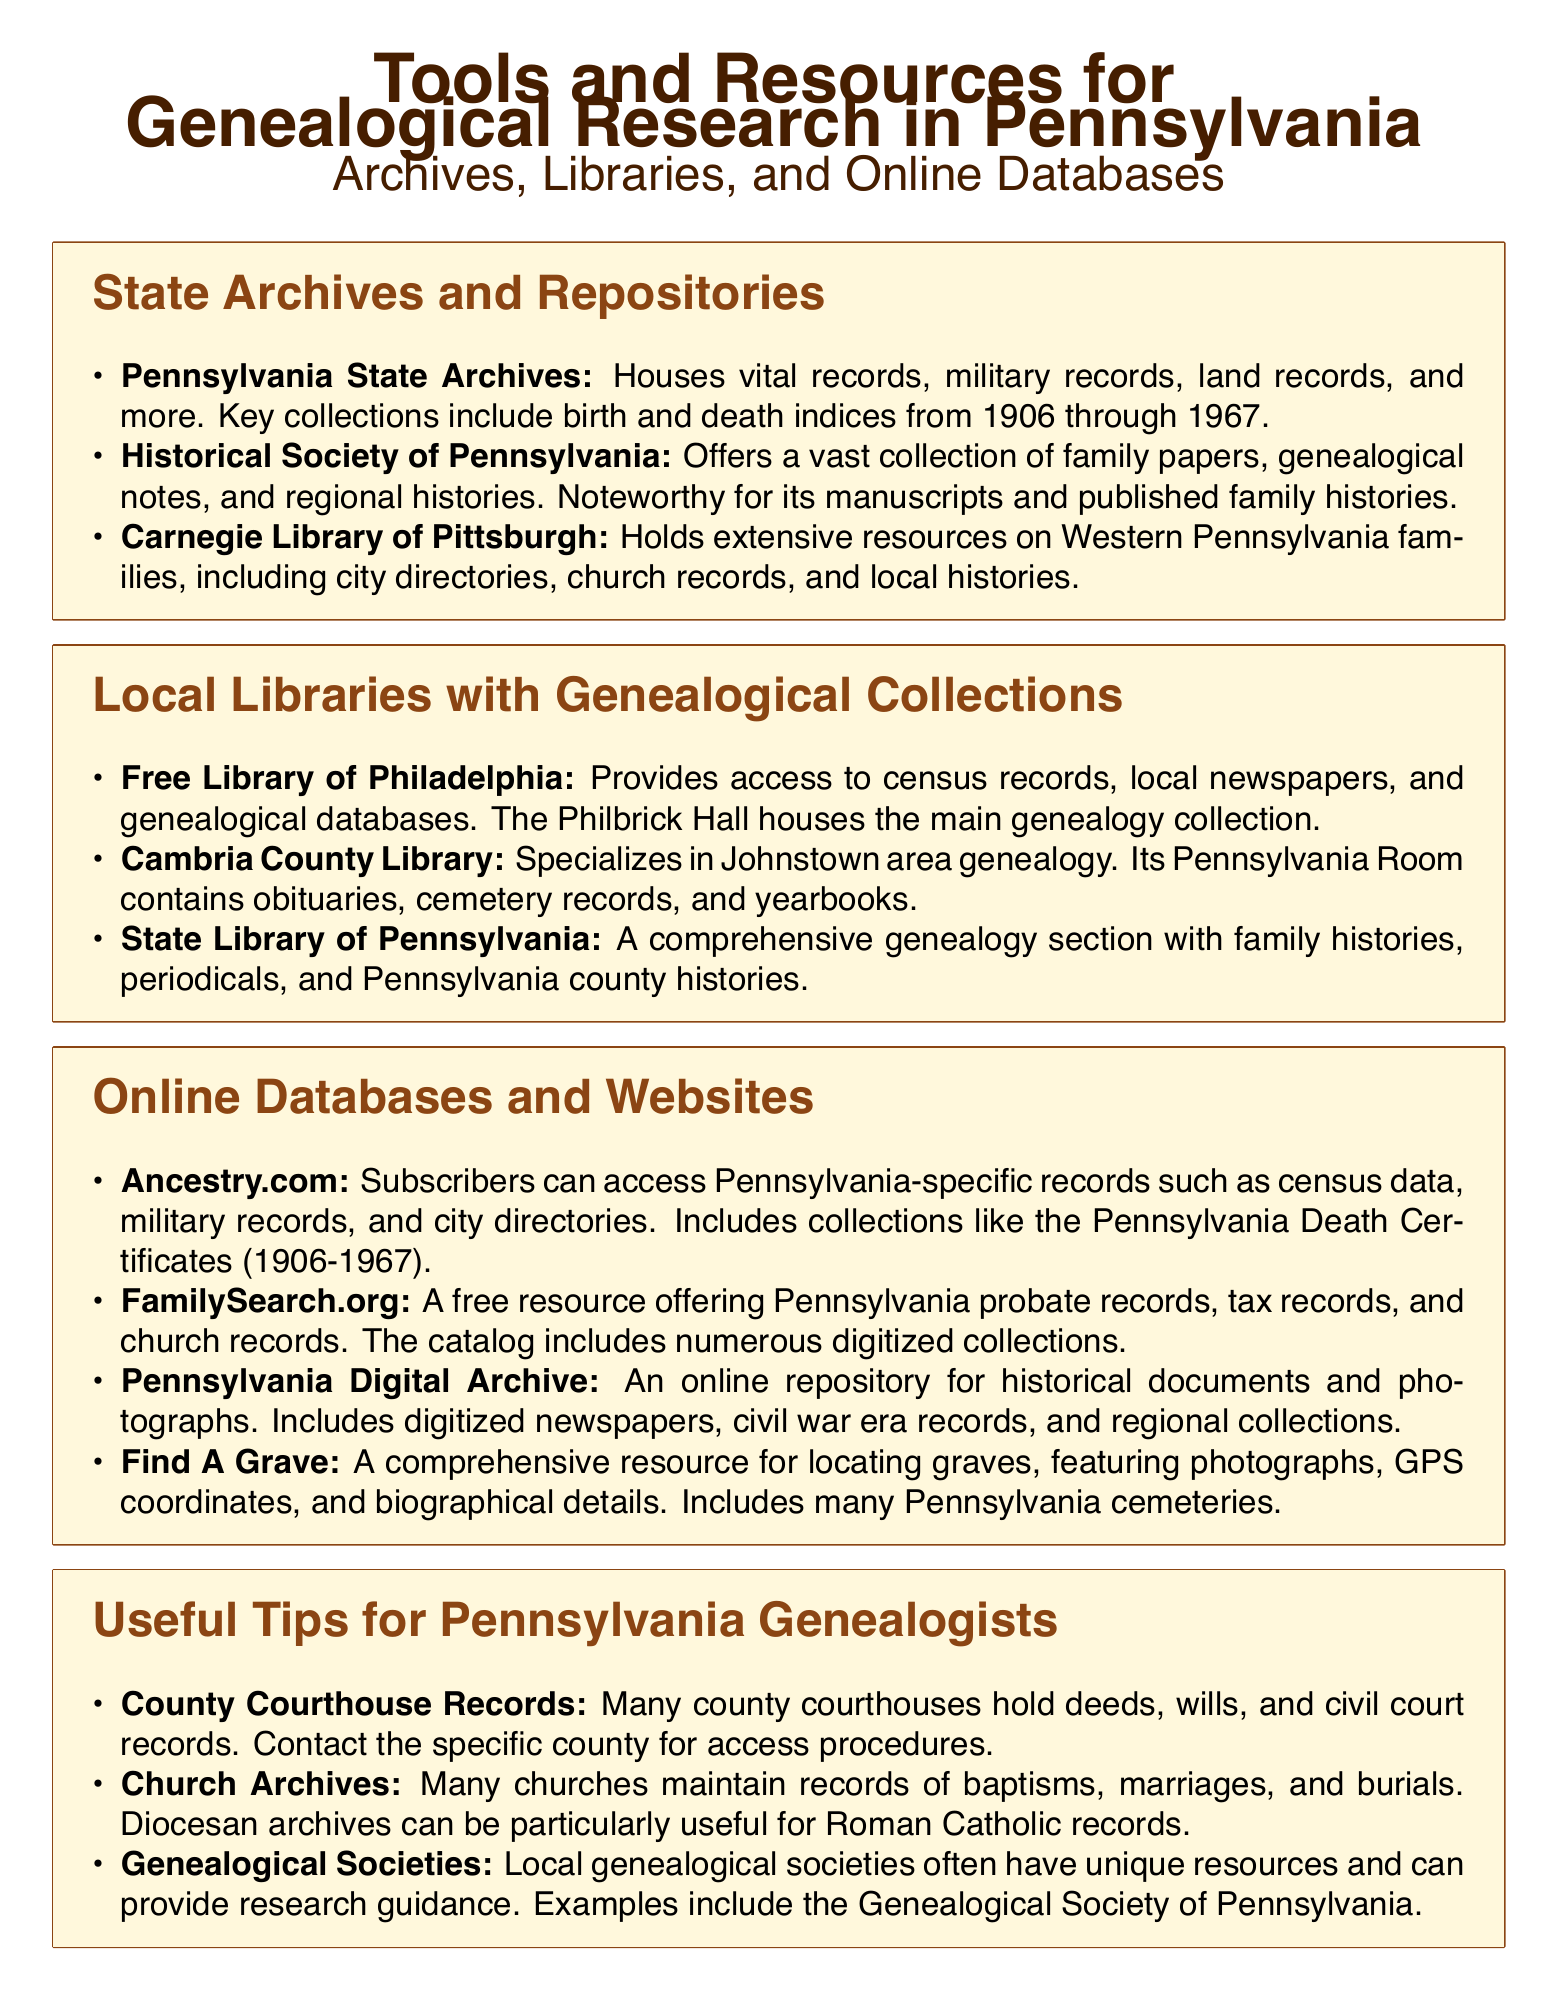What is housed at the Pennsylvania State Archives? The Pennsylvania State Archives houses vital records, military records, land records, and more.
Answer: Vital records, military records, land records Which library specializes in Johnstown area genealogy? The Cambria County Library specializes in Johnstown area genealogy.
Answer: Cambria County Library What online resource offers free access to Pennsylvania probate records? FamilySearch.org is a free resource offering Pennsylvania probate records.
Answer: FamilySearch.org What type of records can be found in the Free Library of Philadelphia? The Free Library of Philadelphia provides access to census records, local newspapers, and genealogical databases.
Answer: Census records, local newspapers, genealogical databases Which entity might you contact for access to courthouse records? You would contact the specific county for access procedures to courthouse records.
Answer: Specific county What is a key feature of Find A Grave? Find A Grave features photographs, GPS coordinates, and biographical details of graves.
Answer: Photographs, GPS coordinates, biographical details What types of records do church archives often maintain? Church archives often maintain records of baptisms, marriages, and burials.
Answer: Baptisms, marriages, burials Name one resource that includes digitized newspapers. The Pennsylvania Digital Archive is an online repository for historical documents and digitized newspapers.
Answer: Pennsylvania Digital Archive 